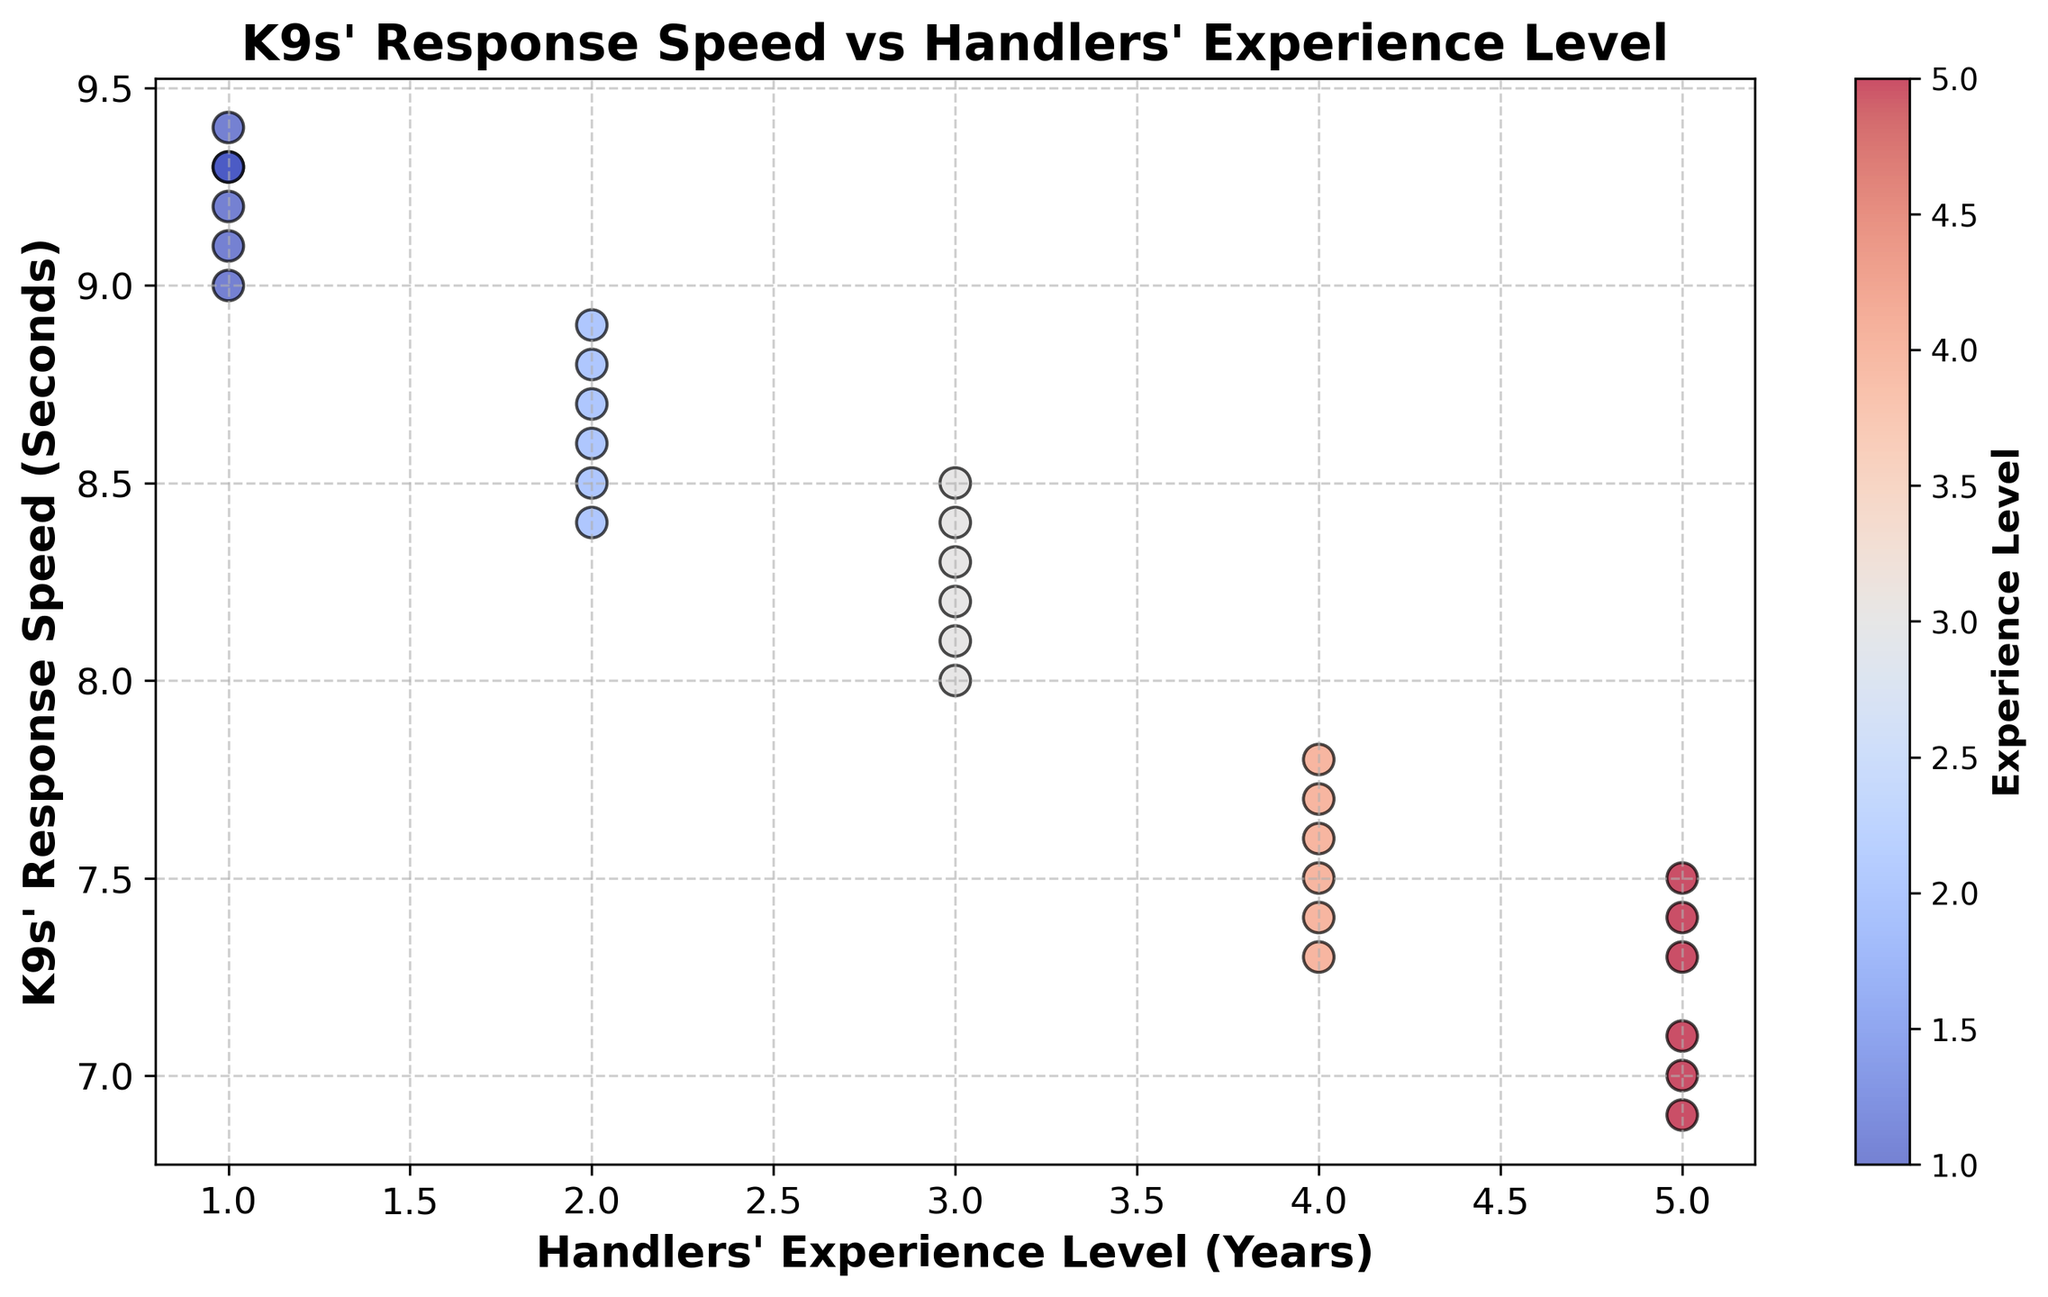What is the general trend observed between handlers' experience level and K9s' response speed? From the scatter plot, it is apparent that as the handlers' experience level increases from 1 to 5 years, the K9s' response speed generally decreases. This suggests a negative correlation between experience level and response speed.
Answer: Negative correlation Which handlers' experience level has the fastest K9 response speed on average? By visually scanning the scatter plot, the handlers with experience levels of 5 years show the lowest response speeds overall compared to other experience levels.
Answer: 5 years What is the difference in K9 response speed between handlers with 1 year of experience and those with 5 years of experience? The response speeds for handlers with 1 year experience range around 9.0 to 9.4 seconds, while for 5 years of experience, it ranges around 6.9 to 7.5 seconds. Taking approximate middle values, the difference is around 9.2 - 7.2 = 2 seconds.
Answer: 2 seconds Is there any overlap in the response speed ranges for different experience levels? By visually comparing the clusters of data points, it can be observed that there is slight overlap primarily between adjacent levels (e.g., 3 and 4 years), but generally very little overlap between experience levels like 1 and 5 years.
Answer: Slight overlap What can be inferred if a particular handler's experience level is colored in a deep red on the scatter plot? Based on the color scheme where experience levels are mapped to colors using a coolwarm colormap, a deep red indicates a higher experience level, likely indicating a handler with around 5 years of experience.
Answer: Higher experience level What is the median response speed for handlers with 3 years of experience? To find the median response speed for handlers with 3 years of experience, locate the response speeds for this group in the plot (8.0, 8.1, 8.2, 8.3, 8.4, and 8.5) and find the median value. Median = (8.2 + 8.3) / 2 = 8.25 seconds.
Answer: 8.25 seconds Compare the spread of K9s' response speeds for handlers with 4 years of experience to those with 2 years of experience. Which group shows more variability? Handlers with 4 years of experience have response speeds ranging from 7.3 to 7.8 seconds, while those with 2 years experience range from 8.4 to 8.9 seconds. By observing the range (7.8-7.3 = 0.5 for 4 years and 8.9-8.4 = 0.5 for 2 years), they show similar variability.
Answer: Similar variability How does the color intensity of the scatter points change with increasing experience levels? By observing the scatter plot, it is noted that points representing higher experience levels (e.g., 4 to 5 years) are depicted with more intense colors towards the red spectrum, while lower experience levels (1 to 2 years) are in lighter to cooler colors.
Answer: More intense, red spectrum What is the significance of the black edge color around the scatter points? The black edge highlights each scatter point on the plot, making it easier to distinguish individual data points and improve visual clarity regardless of their color.
Answer: Improved visual clarity Are there any outliers in the response speeds of K9s for a specific experience level? A visual scan of the scatter plot shows that the response speeds are clustered closely within their respective experience levels, with no visible points far removed from their cluster. Therefore, there are no significant outliers.
Answer: No significant outliers 